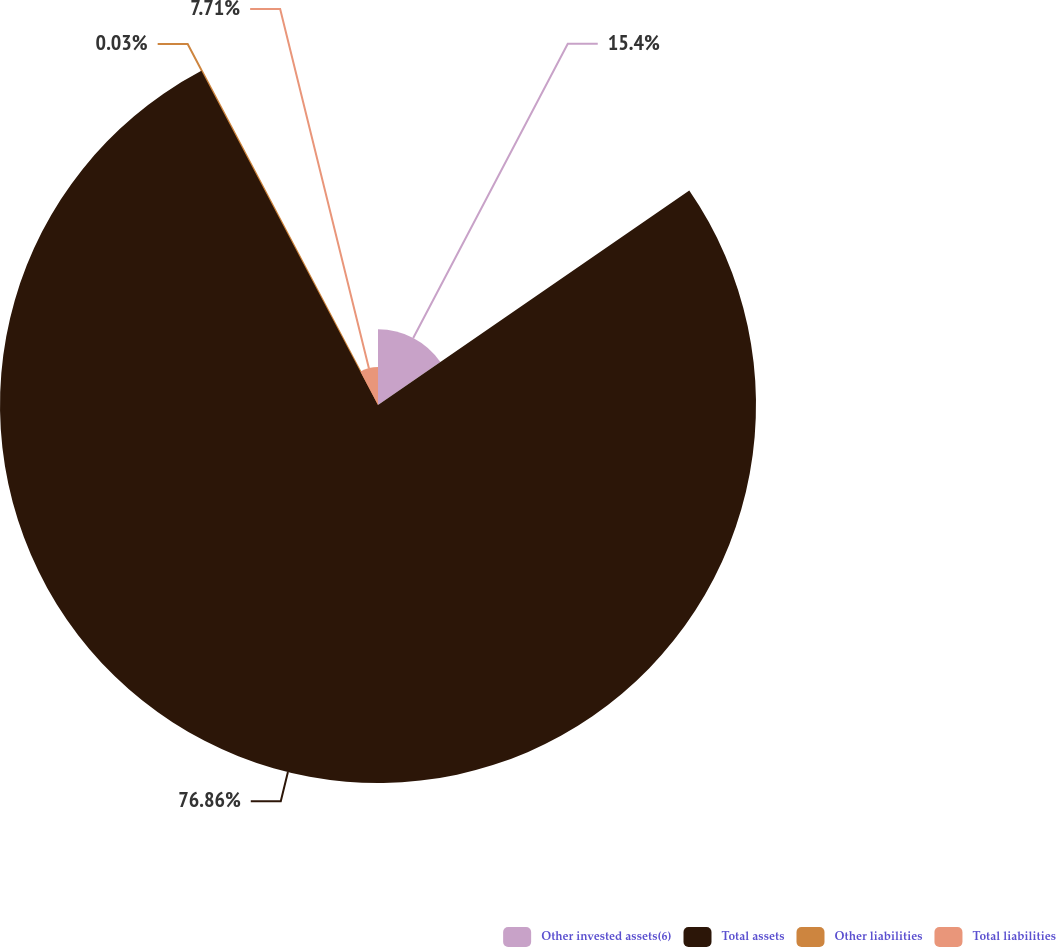Convert chart. <chart><loc_0><loc_0><loc_500><loc_500><pie_chart><fcel>Other invested assets(6)<fcel>Total assets<fcel>Other liabilities<fcel>Total liabilities<nl><fcel>15.4%<fcel>76.87%<fcel>0.03%<fcel>7.71%<nl></chart> 